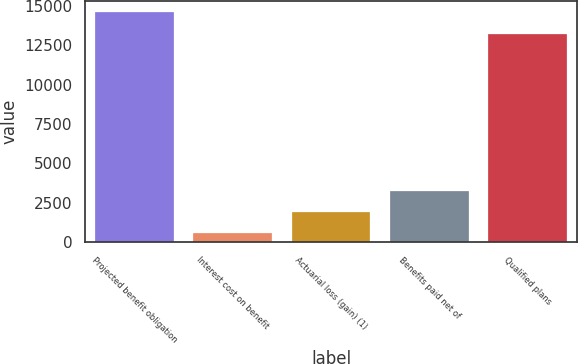Convert chart. <chart><loc_0><loc_0><loc_500><loc_500><bar_chart><fcel>Projected benefit obligation<fcel>Interest cost on benefit<fcel>Actuarial loss (gain) (1)<fcel>Benefits paid net of<fcel>Qualified plans<nl><fcel>14581.7<fcel>553<fcel>1903.7<fcel>3254.4<fcel>13231<nl></chart> 